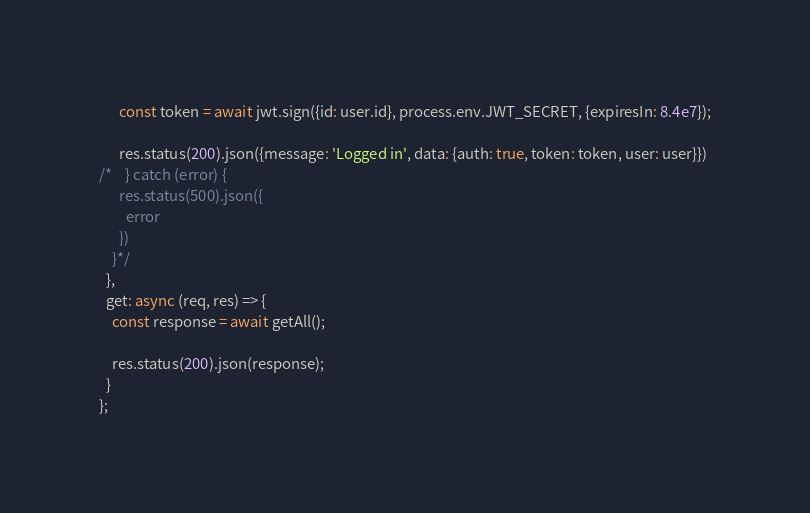Convert code to text. <code><loc_0><loc_0><loc_500><loc_500><_JavaScript_>      const token = await jwt.sign({id: user.id}, process.env.JWT_SECRET, {expiresIn: 8.4e7});

      res.status(200).json({message: 'Logged in', data: {auth: true, token: token, user: user}})
/*    } catch (error) {
      res.status(500).json({
        error
      })
    }*/
  },
  get: async (req, res) => {
    const response = await getAll();

    res.status(200).json(response);
  }
};</code> 